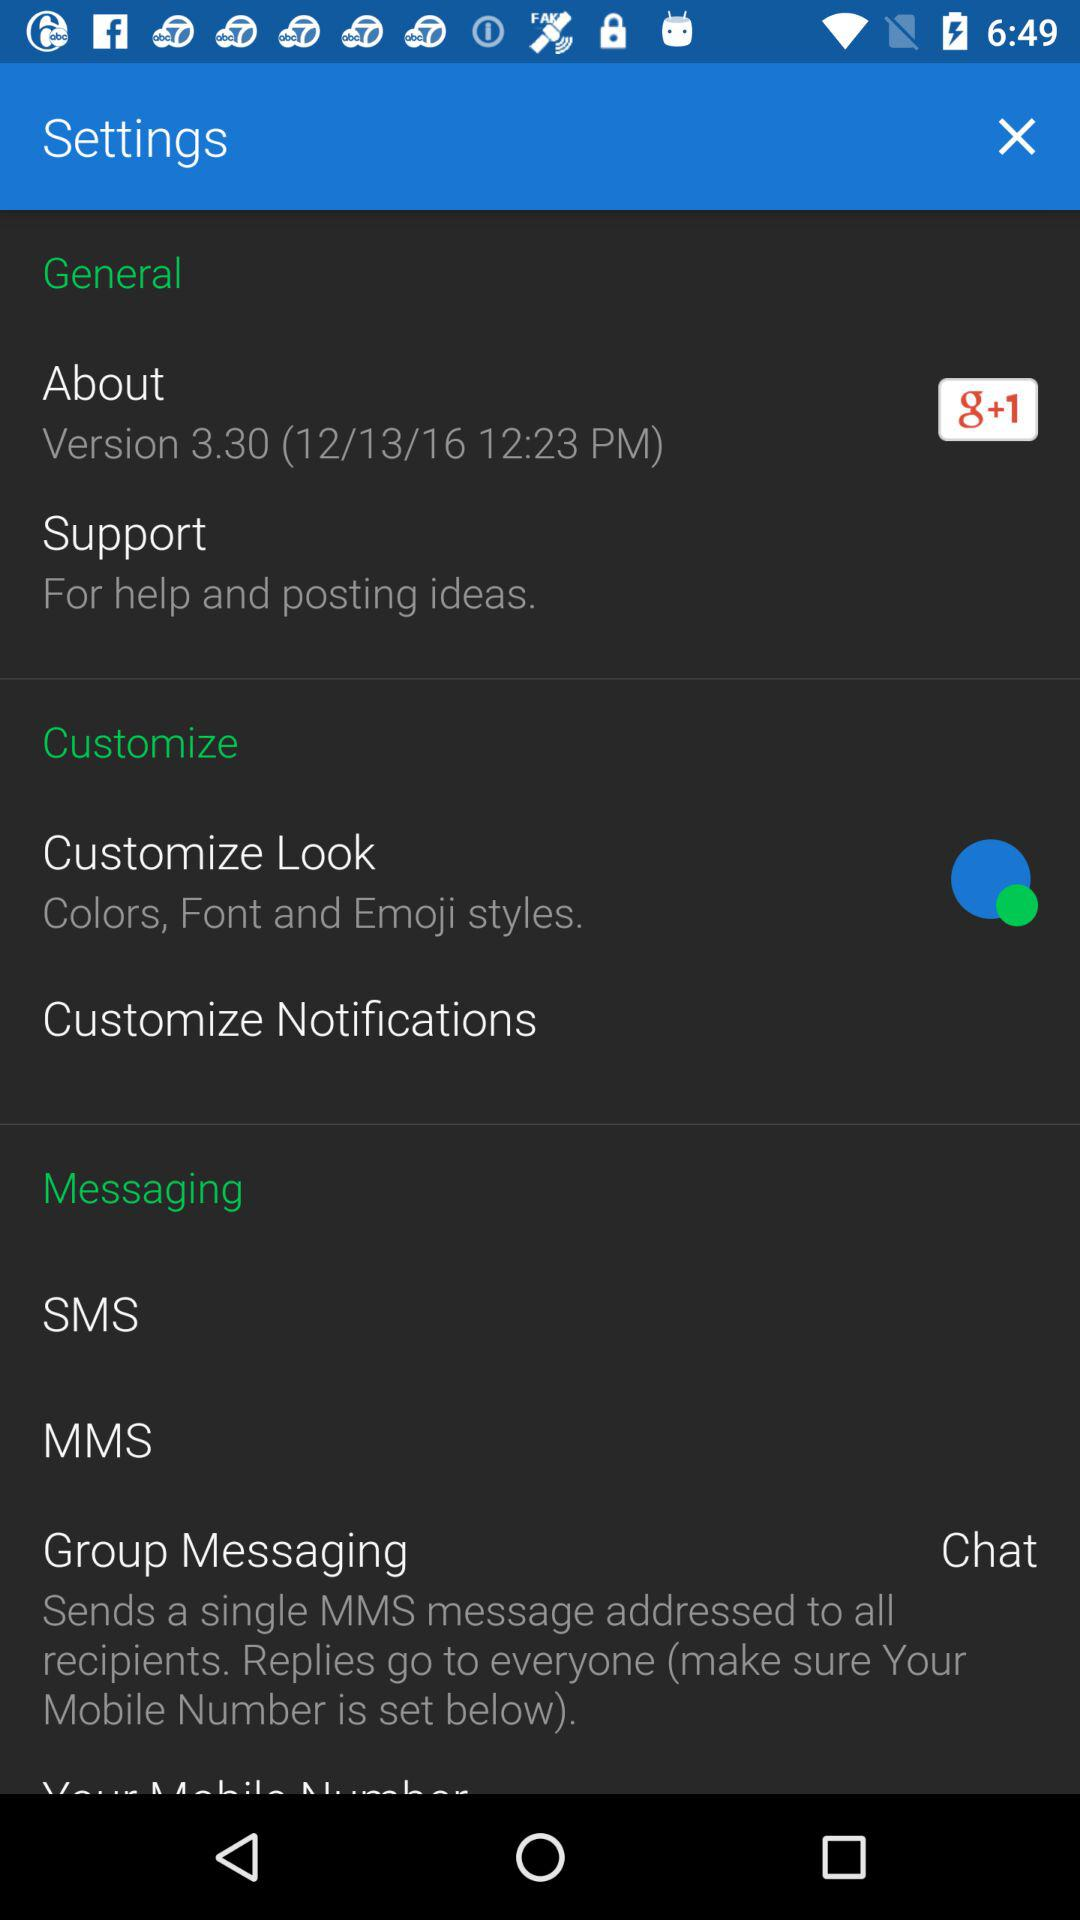Which font was selected?
When the provided information is insufficient, respond with <no answer>. <no answer> 